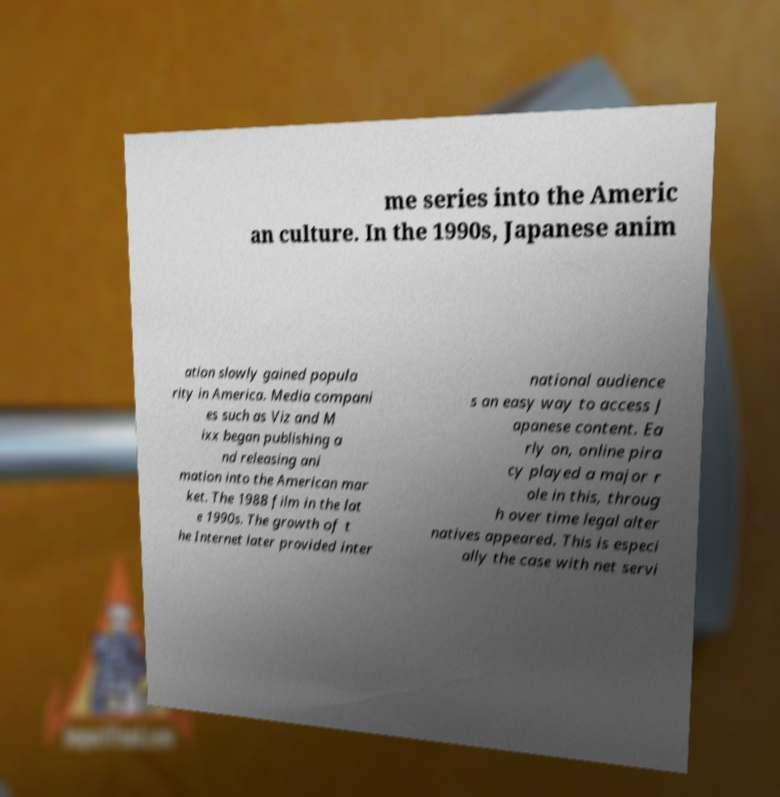For documentation purposes, I need the text within this image transcribed. Could you provide that? me series into the Americ an culture. In the 1990s, Japanese anim ation slowly gained popula rity in America. Media compani es such as Viz and M ixx began publishing a nd releasing ani mation into the American mar ket. The 1988 film in the lat e 1990s. The growth of t he Internet later provided inter national audience s an easy way to access J apanese content. Ea rly on, online pira cy played a major r ole in this, throug h over time legal alter natives appeared. This is especi ally the case with net servi 